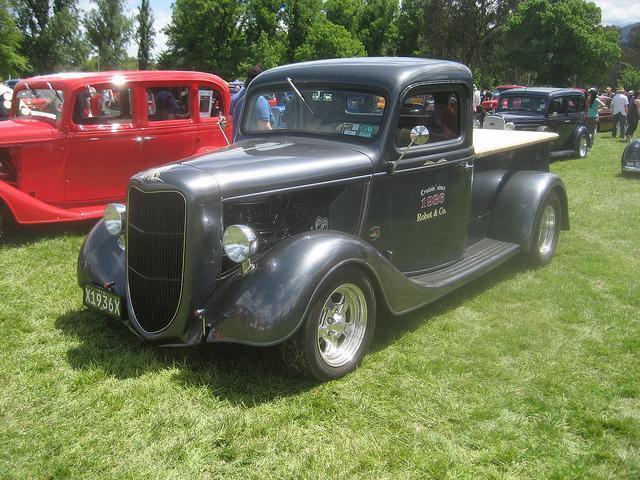How many cars are there?
Give a very brief answer. 1. 